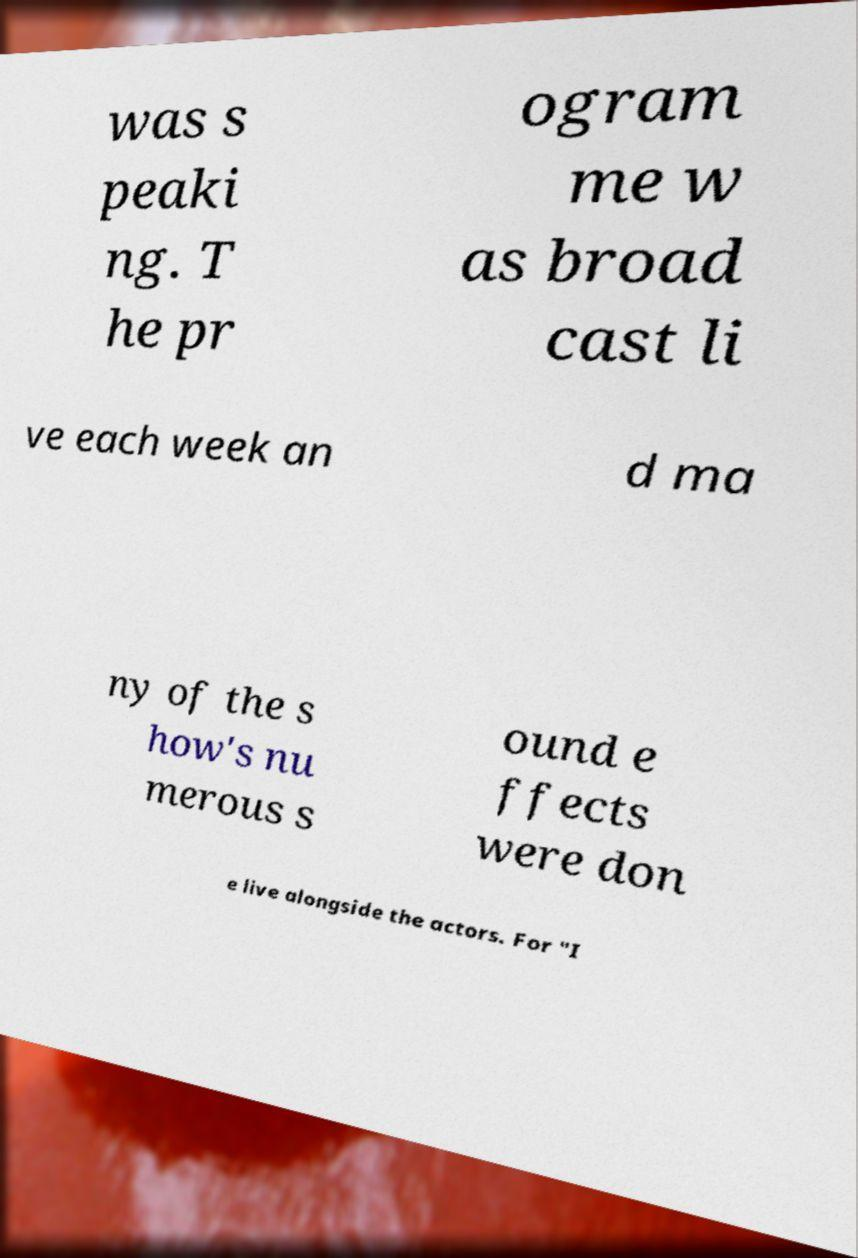I need the written content from this picture converted into text. Can you do that? was s peaki ng. T he pr ogram me w as broad cast li ve each week an d ma ny of the s how's nu merous s ound e ffects were don e live alongside the actors. For "I 